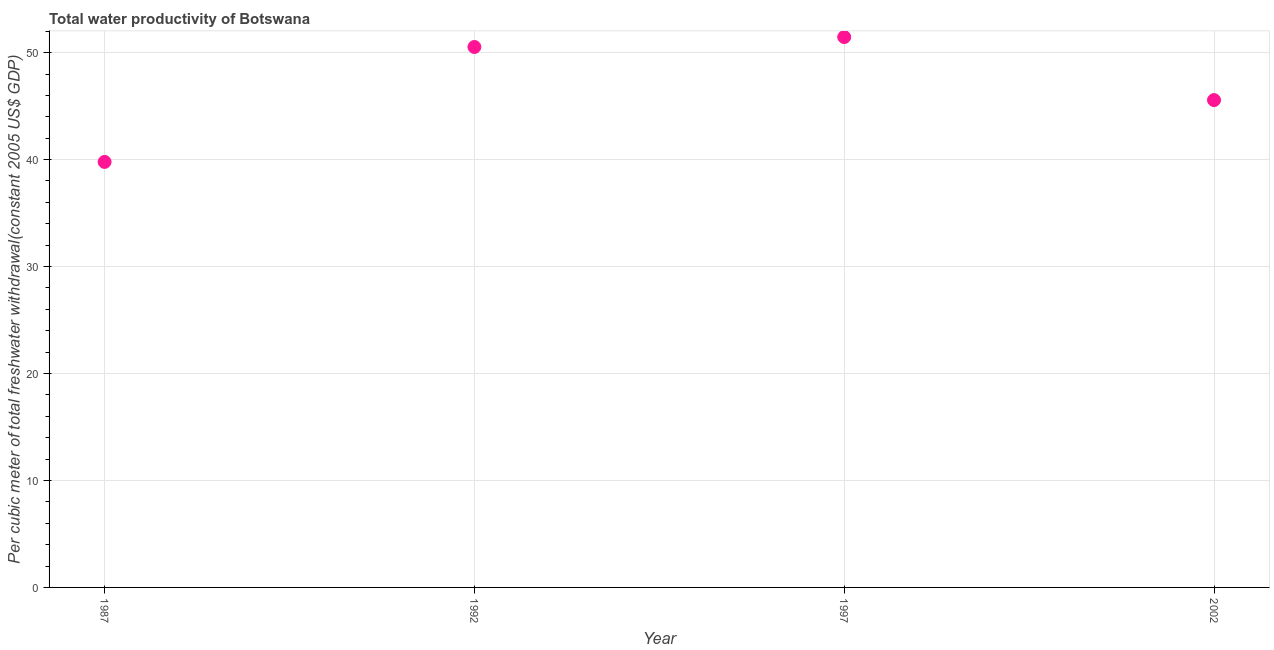What is the total water productivity in 1987?
Your answer should be very brief. 39.78. Across all years, what is the maximum total water productivity?
Offer a very short reply. 51.46. Across all years, what is the minimum total water productivity?
Give a very brief answer. 39.78. What is the sum of the total water productivity?
Offer a terse response. 187.33. What is the difference between the total water productivity in 1992 and 1997?
Offer a terse response. -0.93. What is the average total water productivity per year?
Offer a very short reply. 46.83. What is the median total water productivity?
Your response must be concise. 48.05. What is the ratio of the total water productivity in 1997 to that in 2002?
Give a very brief answer. 1.13. Is the difference between the total water productivity in 1992 and 2002 greater than the difference between any two years?
Provide a short and direct response. No. What is the difference between the highest and the second highest total water productivity?
Your answer should be very brief. 0.93. What is the difference between the highest and the lowest total water productivity?
Provide a succinct answer. 11.67. How many years are there in the graph?
Offer a very short reply. 4. What is the difference between two consecutive major ticks on the Y-axis?
Give a very brief answer. 10. Are the values on the major ticks of Y-axis written in scientific E-notation?
Your answer should be compact. No. Does the graph contain any zero values?
Provide a succinct answer. No. What is the title of the graph?
Give a very brief answer. Total water productivity of Botswana. What is the label or title of the Y-axis?
Ensure brevity in your answer.  Per cubic meter of total freshwater withdrawal(constant 2005 US$ GDP). What is the Per cubic meter of total freshwater withdrawal(constant 2005 US$ GDP) in 1987?
Your answer should be very brief. 39.78. What is the Per cubic meter of total freshwater withdrawal(constant 2005 US$ GDP) in 1992?
Your answer should be very brief. 50.53. What is the Per cubic meter of total freshwater withdrawal(constant 2005 US$ GDP) in 1997?
Your answer should be compact. 51.46. What is the Per cubic meter of total freshwater withdrawal(constant 2005 US$ GDP) in 2002?
Offer a terse response. 45.56. What is the difference between the Per cubic meter of total freshwater withdrawal(constant 2005 US$ GDP) in 1987 and 1992?
Your response must be concise. -10.75. What is the difference between the Per cubic meter of total freshwater withdrawal(constant 2005 US$ GDP) in 1987 and 1997?
Give a very brief answer. -11.67. What is the difference between the Per cubic meter of total freshwater withdrawal(constant 2005 US$ GDP) in 1987 and 2002?
Make the answer very short. -5.78. What is the difference between the Per cubic meter of total freshwater withdrawal(constant 2005 US$ GDP) in 1992 and 1997?
Your answer should be very brief. -0.93. What is the difference between the Per cubic meter of total freshwater withdrawal(constant 2005 US$ GDP) in 1992 and 2002?
Your response must be concise. 4.97. What is the difference between the Per cubic meter of total freshwater withdrawal(constant 2005 US$ GDP) in 1997 and 2002?
Your response must be concise. 5.89. What is the ratio of the Per cubic meter of total freshwater withdrawal(constant 2005 US$ GDP) in 1987 to that in 1992?
Provide a short and direct response. 0.79. What is the ratio of the Per cubic meter of total freshwater withdrawal(constant 2005 US$ GDP) in 1987 to that in 1997?
Your answer should be very brief. 0.77. What is the ratio of the Per cubic meter of total freshwater withdrawal(constant 2005 US$ GDP) in 1987 to that in 2002?
Give a very brief answer. 0.87. What is the ratio of the Per cubic meter of total freshwater withdrawal(constant 2005 US$ GDP) in 1992 to that in 2002?
Ensure brevity in your answer.  1.11. What is the ratio of the Per cubic meter of total freshwater withdrawal(constant 2005 US$ GDP) in 1997 to that in 2002?
Ensure brevity in your answer.  1.13. 